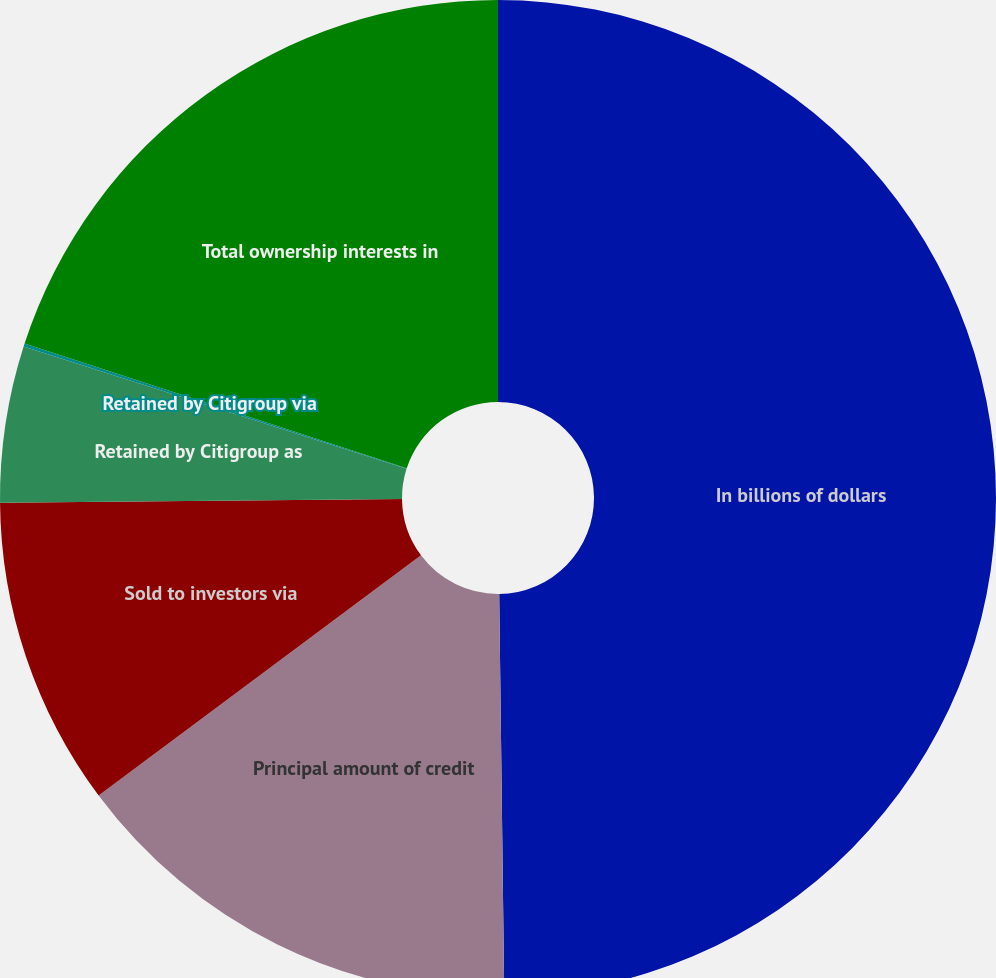Convert chart to OTSL. <chart><loc_0><loc_0><loc_500><loc_500><pie_chart><fcel>In billions of dollars<fcel>Principal amount of credit<fcel>Sold to investors via<fcel>Retained by Citigroup as<fcel>Retained by Citigroup via<fcel>Total ownership interests in<nl><fcel>49.8%<fcel>15.01%<fcel>10.04%<fcel>5.07%<fcel>0.1%<fcel>19.98%<nl></chart> 